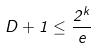Convert formula to latex. <formula><loc_0><loc_0><loc_500><loc_500>D + 1 \leq \frac { 2 ^ { k } } { e }</formula> 